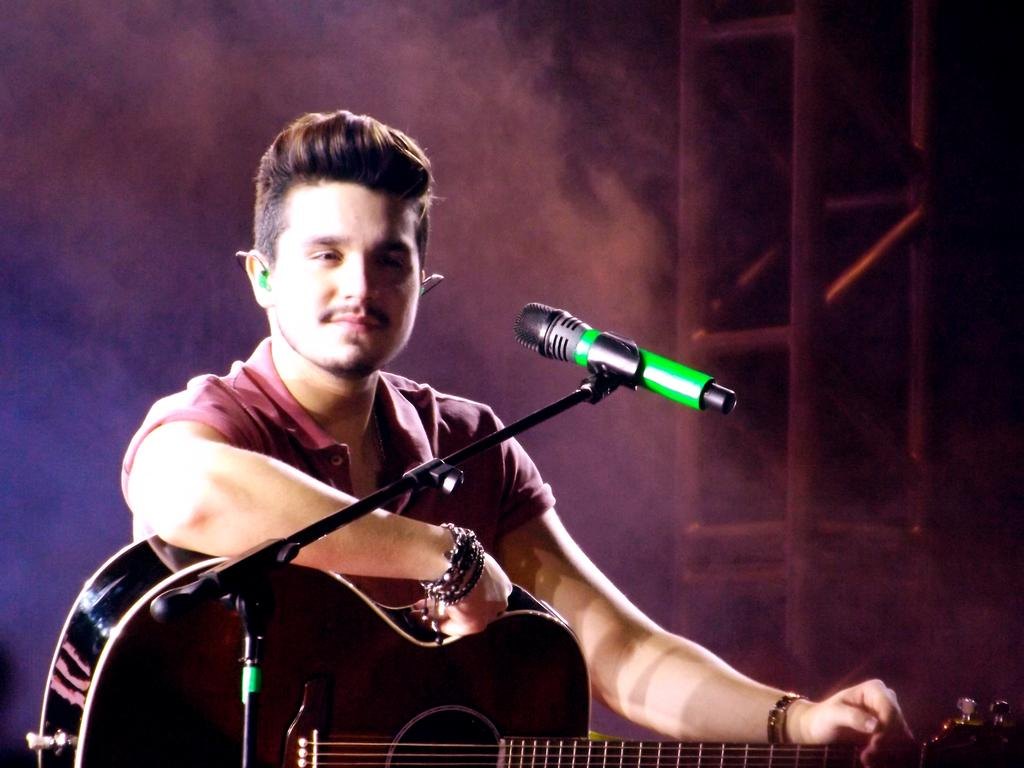What is the person in the image doing? The person is sitting and holding a guitar. What object is present that is commonly used for amplifying sound? There is a microphone with a stand in the image. What can be seen in the background of the image? There is smoke and a rod visible in the background. What type of grass is growing near the person's boot in the image? There is no grass or boot present in the image. What news event is being reported on in the image? There is no news event or reporting present in the image. 